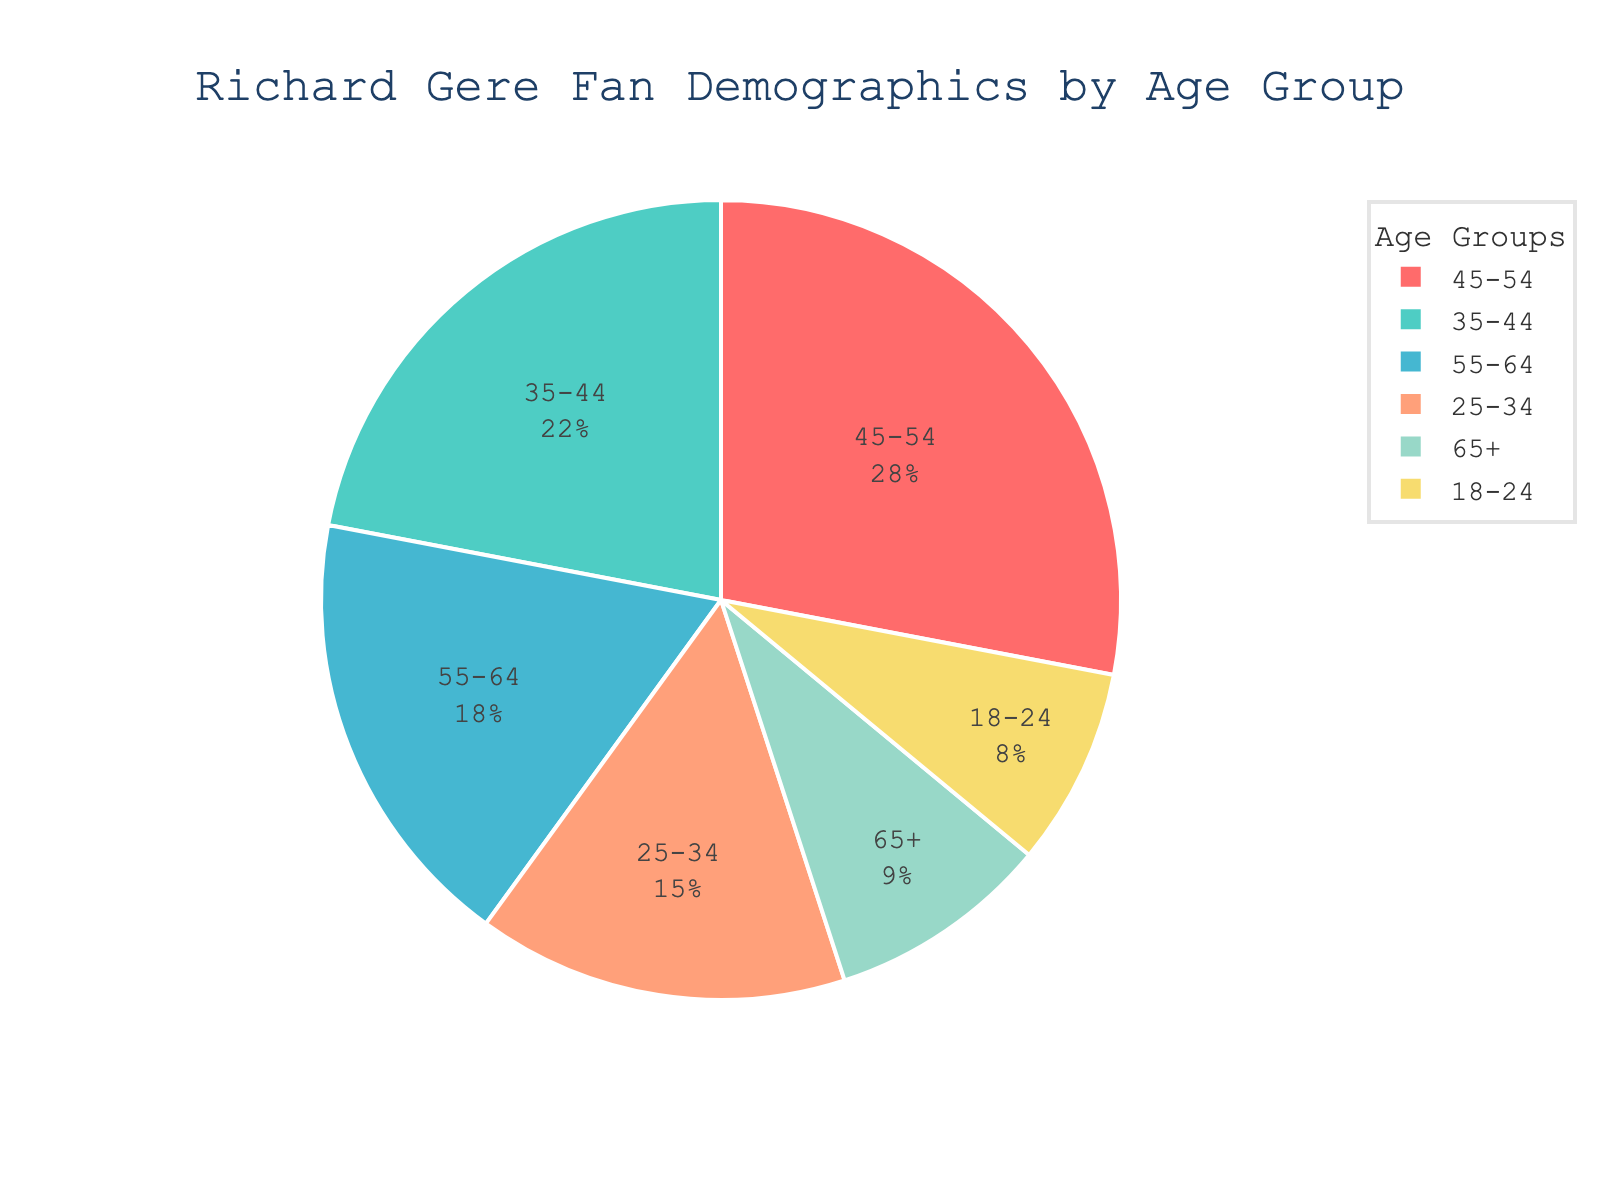What's the most popular age group among Richard Gere's fans? To find the most popular age group, look for the age group with the largest percentage segment in the pie chart. The "45-54" age group has the largest slice.
Answer: 45-54 Which two age groups have the smallest proportions of fans? To determine the smallest proportions, look for the two smallest slices in the pie chart. The "18-24" and "65+" age groups have the smallest slices.
Answer: 18-24 and 65+ What's the combined percentage of fans in the age groups 25-34 and 55-64? Combine the percentages for the "25-34" and "55-64" age groups by adding 15% and 18%.
Answer: 33% Is the percentage of fans aged 35-44 greater than those aged 18-24 and 65+ combined? Add the percentages for "18-24" and "65+" (8% + 9% = 17%), and compare it with the percentage for "35-44" which is 22%. 22% is greater than 17%.
Answer: Yes How much larger is the 45-54 age group's percentage compared to the 18-24 age group's percentage? Subtract the percentage of the "18-24" age group from the "45-54" age group. 28% - 8% = 20%.
Answer: 20% Which age group has a percentage closest to 20%? Look at the pie chart and identify the age group with a percentage closest to 20%. The "35-44" age group has 22%, which is closest.
Answer: 35-44 What is the median percentage value among all age groups? List the percentages: 8%, 9%, 15%, 18%, 22%, and 28%. The median is the middle value of the sorted list. In this case, average the third and fourth values (15% and 18%). (15% + 18%) / 2 = 16.5%.
Answer: 16.5% How does the percentage of fans aged 25-34 compare to those aged 55-64? Compare the percentages directly, with "25-34" having 15% and "55-64" having 18%. The "55-64" age group has a higher percentage.
Answer: 55-64 is higher Which age group is represented by the yellow color on the pie chart? Identify the yellow color and refer to the chart legend. The yellow corresponds to the "55-64" age group.
Answer: 55-64 